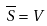<formula> <loc_0><loc_0><loc_500><loc_500>\overline { S } = V</formula> 